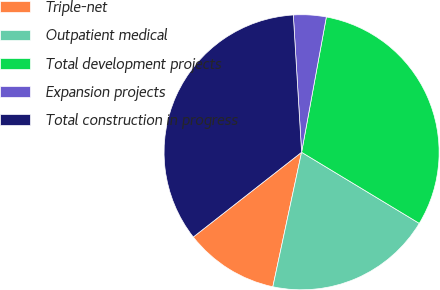Convert chart. <chart><loc_0><loc_0><loc_500><loc_500><pie_chart><fcel>Triple-net<fcel>Outpatient medical<fcel>Total development projects<fcel>Expansion projects<fcel>Total construction in progress<nl><fcel>11.08%<fcel>19.7%<fcel>30.77%<fcel>3.84%<fcel>34.61%<nl></chart> 